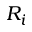Convert formula to latex. <formula><loc_0><loc_0><loc_500><loc_500>R _ { i }</formula> 